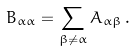<formula> <loc_0><loc_0><loc_500><loc_500>B _ { \alpha \alpha } = \sum _ { \beta \neq \alpha } A _ { \alpha \beta } \, .</formula> 